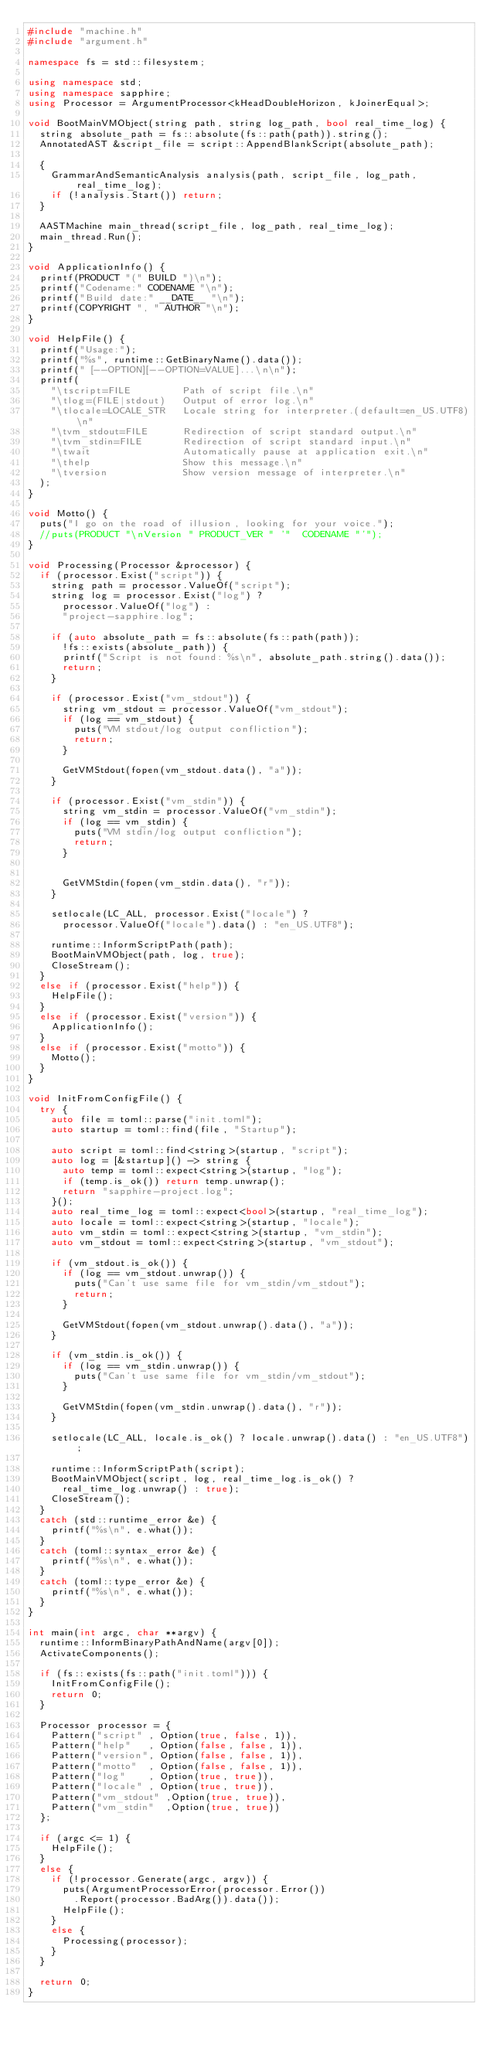Convert code to text. <code><loc_0><loc_0><loc_500><loc_500><_C++_>#include "machine.h"
#include "argument.h"

namespace fs = std::filesystem;

using namespace std;
using namespace sapphire;
using Processor = ArgumentProcessor<kHeadDoubleHorizon, kJoinerEqual>;

void BootMainVMObject(string path, string log_path, bool real_time_log) {
  string absolute_path = fs::absolute(fs::path(path)).string();
  AnnotatedAST &script_file = script::AppendBlankScript(absolute_path);

  {
    GrammarAndSemanticAnalysis analysis(path, script_file, log_path, real_time_log);
    if (!analysis.Start()) return;
  }
  
  AASTMachine main_thread(script_file, log_path, real_time_log);
  main_thread.Run();
}

void ApplicationInfo() {
  printf(PRODUCT "(" BUILD ")\n");
  printf("Codename:" CODENAME "\n");
  printf("Build date:" __DATE__ "\n");
  printf(COPYRIGHT ", " AUTHOR "\n");
}

void HelpFile() {
  printf("Usage:");
  printf("%s", runtime::GetBinaryName().data());
  printf(" [--OPTION][--OPTION=VALUE]...\n\n");
  printf(
    "\tscript=FILE         Path of script file.\n"
    "\tlog=(FILE|stdout)   Output of error log.\n"
    "\tlocale=LOCALE_STR   Locale string for interpreter.(default=en_US.UTF8)\n"
    "\tvm_stdout=FILE      Redirection of script standard output.\n"
    "\tvm_stdin=FILE       Redirection of script standard input.\n"
    "\twait                Automatically pause at application exit.\n"
    "\thelp                Show this message.\n"
    "\tversion             Show version message of interpreter.\n"
  );
}

void Motto() {
  puts("I go on the road of illusion, looking for your voice.");
  //puts(PRODUCT "\nVersion " PRODUCT_VER " '"  CODENAME "'");
}

void Processing(Processor &processor) {
  if (processor.Exist("script")) {
    string path = processor.ValueOf("script");
    string log = processor.Exist("log") ?
      processor.ValueOf("log") :
      "project-sapphire.log";

    if (auto absolute_path = fs::absolute(fs::path(path)); 
      !fs::exists(absolute_path)) {
      printf("Script is not found: %s\n", absolute_path.string().data());
      return;
    }

    if (processor.Exist("vm_stdout")) {
      string vm_stdout = processor.ValueOf("vm_stdout");
      if (log == vm_stdout) {
        puts("VM stdout/log output confliction");
        return;
      }

      GetVMStdout(fopen(vm_stdout.data(), "a"));
    }

    if (processor.Exist("vm_stdin")) {
      string vm_stdin = processor.ValueOf("vm_stdin");
      if (log == vm_stdin) {
        puts("VM stdin/log output confliction");
        return;
      }


      GetVMStdin(fopen(vm_stdin.data(), "r"));
    }

    setlocale(LC_ALL, processor.Exist("locale") ?
      processor.ValueOf("locale").data() : "en_US.UTF8");

    runtime::InformScriptPath(path);
    BootMainVMObject(path, log, true);
    CloseStream();
  }
  else if (processor.Exist("help")) {
    HelpFile();
  }
  else if (processor.Exist("version")) {
    ApplicationInfo();
  }
  else if (processor.Exist("motto")) {
    Motto();
  }
}

void InitFromConfigFile() {
  try {
    auto file = toml::parse("init.toml");
    auto startup = toml::find(file, "Startup");

    auto script = toml::find<string>(startup, "script");
    auto log = [&startup]() -> string {
      auto temp = toml::expect<string>(startup, "log");
      if (temp.is_ok()) return temp.unwrap();
      return "sapphire-project.log";
    }();
    auto real_time_log = toml::expect<bool>(startup, "real_time_log");
    auto locale = toml::expect<string>(startup, "locale");
    auto vm_stdin = toml::expect<string>(startup, "vm_stdin");
    auto vm_stdout = toml::expect<string>(startup, "vm_stdout");

    if (vm_stdout.is_ok()) {
      if (log == vm_stdout.unwrap()) {
        puts("Can't use same file for vm_stdin/vm_stdout");
        return;
      }

      GetVMStdout(fopen(vm_stdout.unwrap().data(), "a"));
    }

    if (vm_stdin.is_ok()) {
      if (log == vm_stdin.unwrap()) {
        puts("Can't use same file for vm_stdin/vm_stdout");
      }

      GetVMStdin(fopen(vm_stdin.unwrap().data(), "r"));
    }

    setlocale(LC_ALL, locale.is_ok() ? locale.unwrap().data() : "en_US.UTF8");

    runtime::InformScriptPath(script);
    BootMainVMObject(script, log, real_time_log.is_ok() ?
      real_time_log.unwrap() : true);
    CloseStream();
  }
  catch (std::runtime_error &e) {
    printf("%s\n", e.what());
  }
  catch (toml::syntax_error &e) {
    printf("%s\n", e.what());
  }
  catch (toml::type_error &e) {
    printf("%s\n", e.what());
  }
}

int main(int argc, char **argv) {
  runtime::InformBinaryPathAndName(argv[0]);
  ActivateComponents();

  if (fs::exists(fs::path("init.toml"))) {
    InitFromConfigFile();
    return 0;
  }

  Processor processor = {
    Pattern("script" , Option(true, false, 1)),
    Pattern("help"   , Option(false, false, 1)),
    Pattern("version", Option(false, false, 1)),
    Pattern("motto"  , Option(false, false, 1)),
    Pattern("log"    , Option(true, true)),
    Pattern("locale" , Option(true, true)),
    Pattern("vm_stdout" ,Option(true, true)),
    Pattern("vm_stdin"  ,Option(true, true))
  };

  if (argc <= 1) {
    HelpFile();
  }
  else {
    if (!processor.Generate(argc, argv)) {
      puts(ArgumentProcessorError(processor.Error())
        .Report(processor.BadArg()).data());
      HelpFile();
    }
    else {
      Processing(processor);
    }
  }

  return 0;
}
</code> 